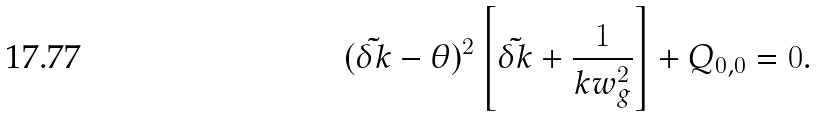<formula> <loc_0><loc_0><loc_500><loc_500>( \tilde { \delta k } - \theta ) ^ { 2 } \left [ \tilde { \delta k } + \frac { 1 } { k w _ { g } ^ { 2 } } \right ] + Q _ { 0 , 0 } = 0 .</formula> 